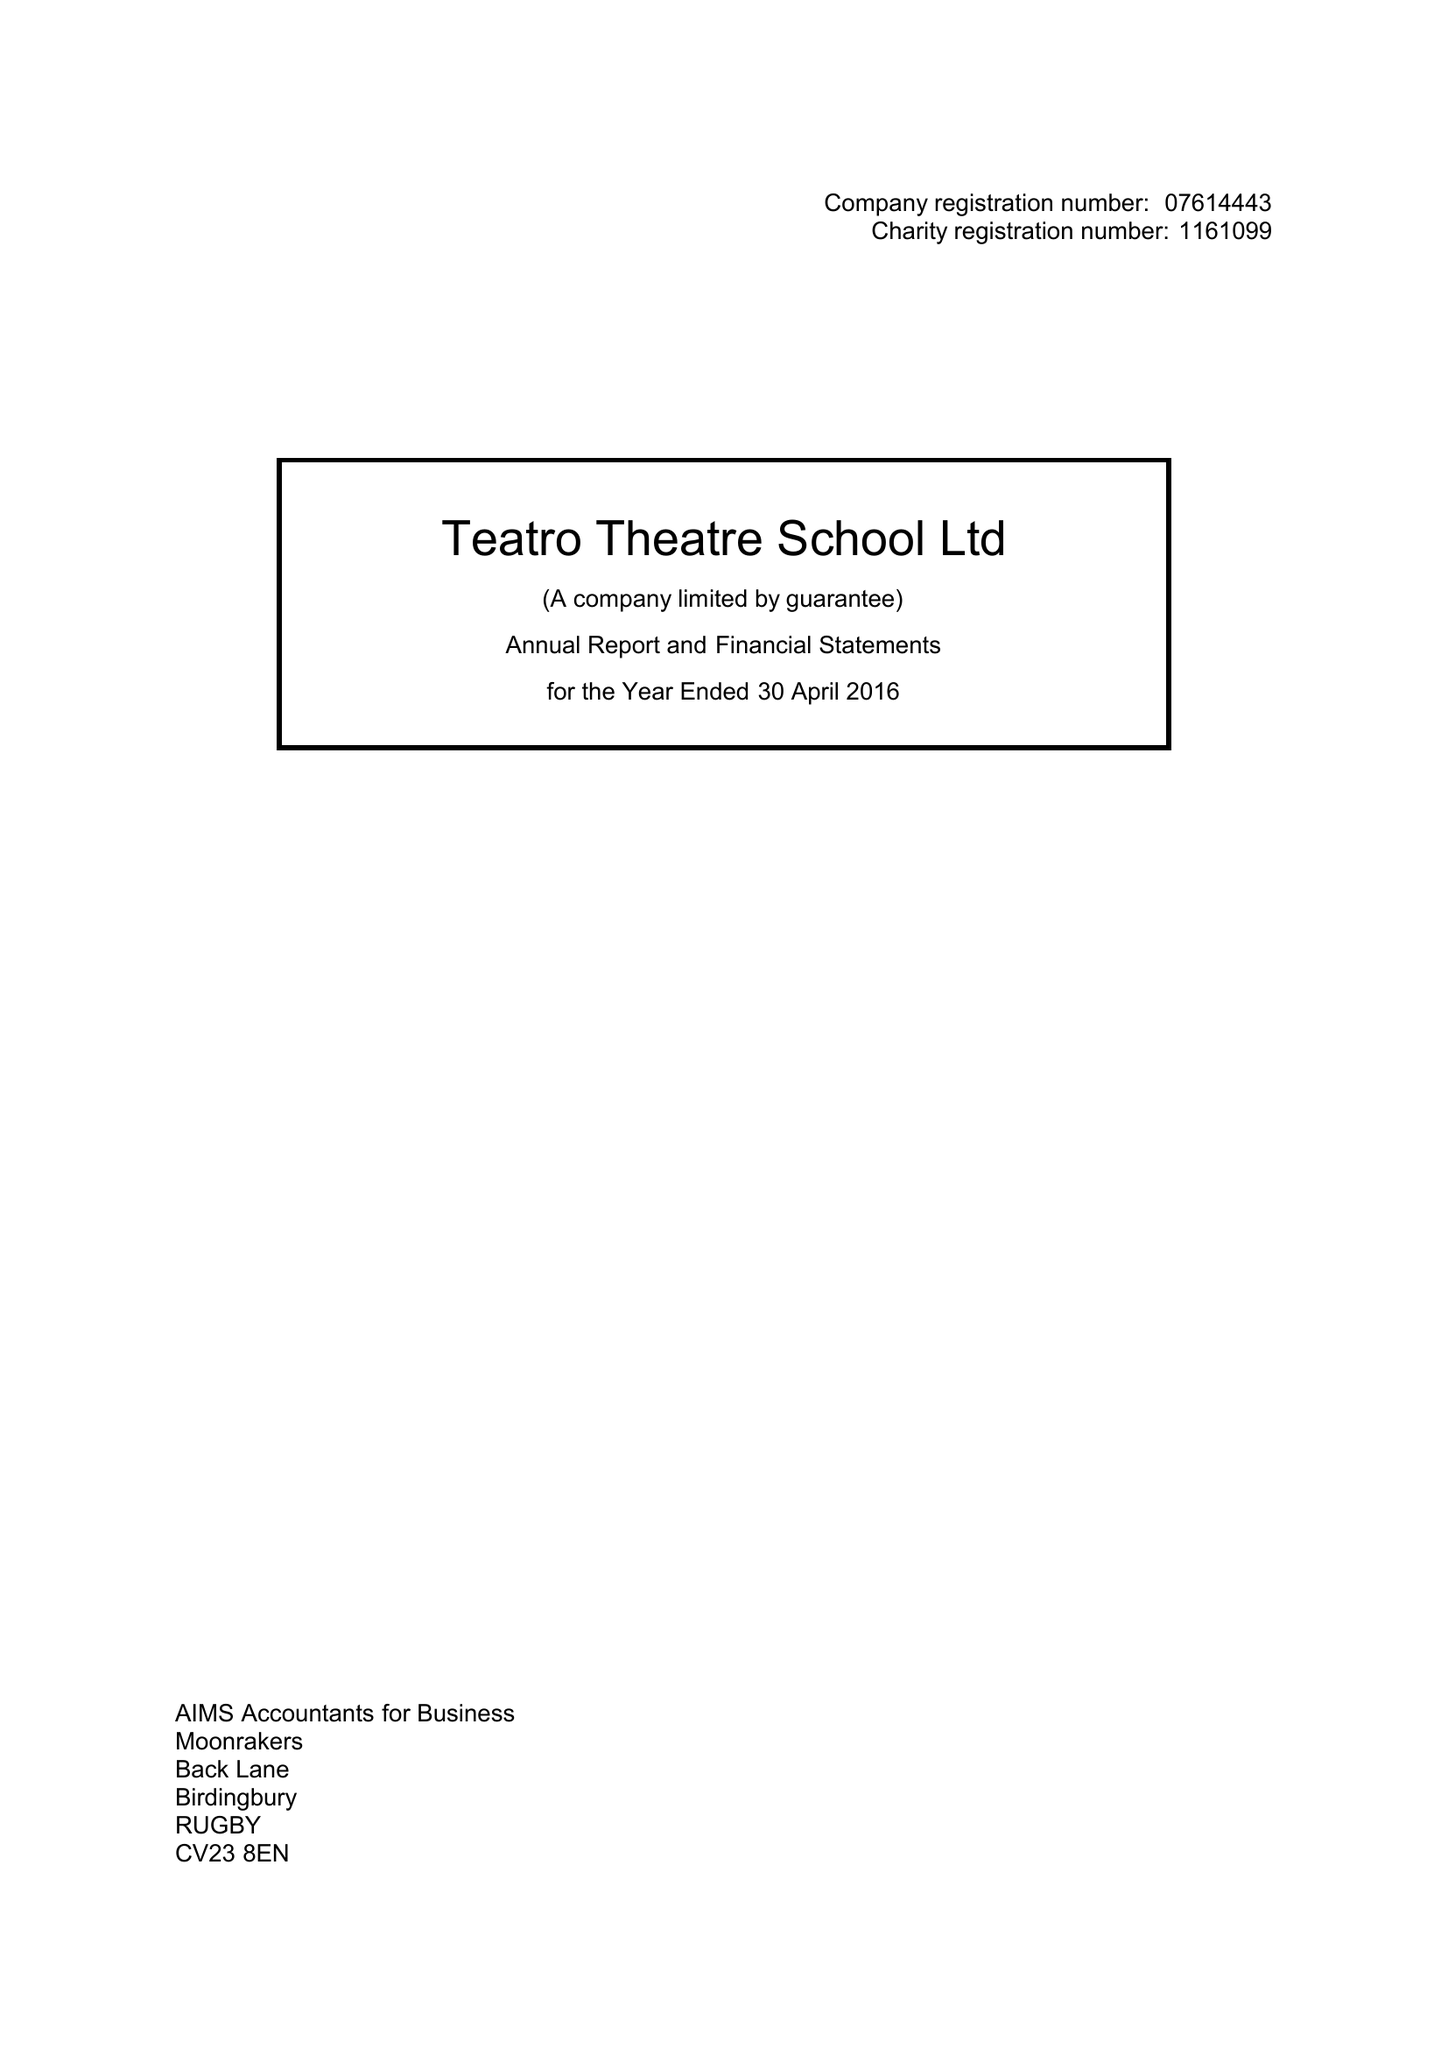What is the value for the income_annually_in_british_pounds?
Answer the question using a single word or phrase. 25789.00 